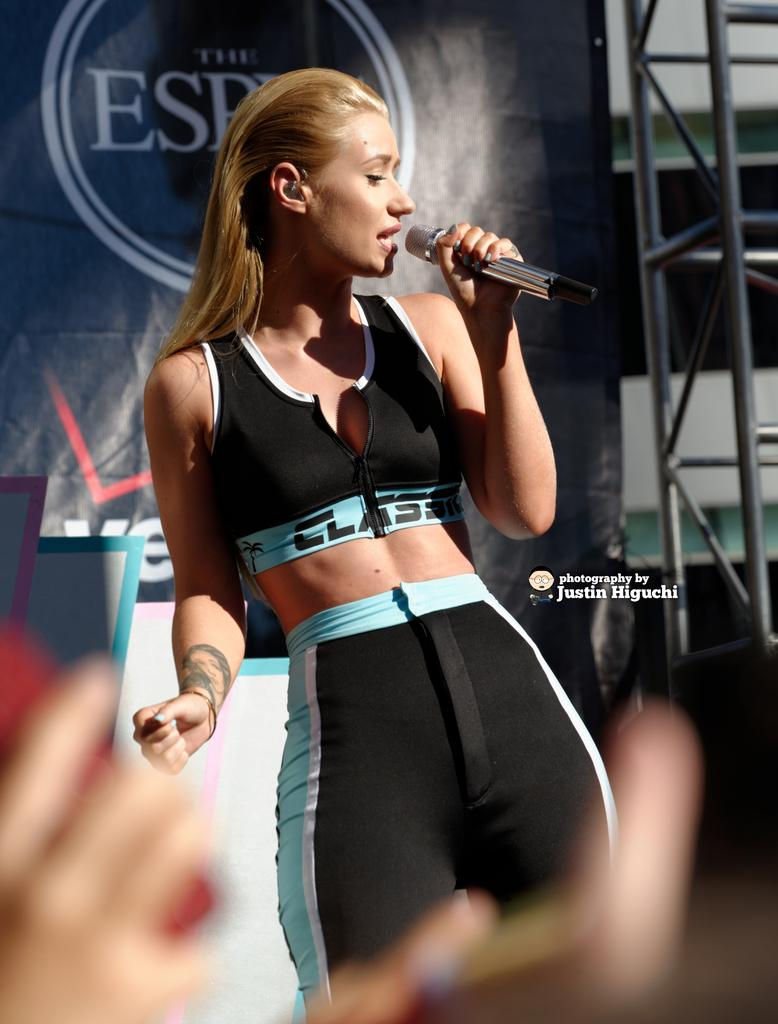Who is the main subject in the image? There is a woman in the image. What is the woman doing in the image? The woman is singing. What object is the woman holding in the image? The woman is holding a microphone. What can be seen in the background of the image? There is a banner in the background of the image. What type of cloth is the beggar using to cover their face in the image? There is no beggar present in the image, and therefore no cloth covering a face can be observed. 